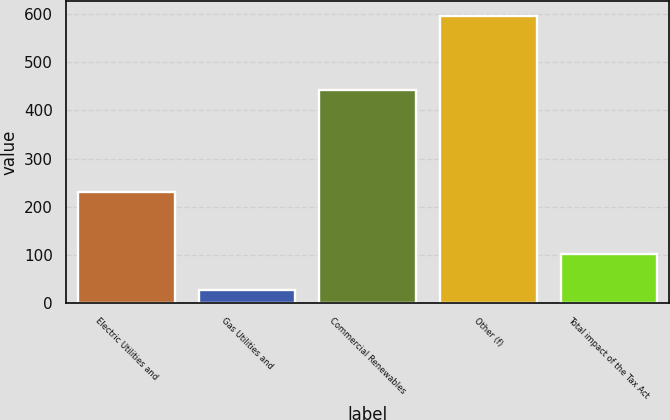Convert chart to OTSL. <chart><loc_0><loc_0><loc_500><loc_500><bar_chart><fcel>Electric Utilities and<fcel>Gas Utilities and<fcel>Commercial Renewables<fcel>Other (f)<fcel>Total impact of the Tax Act<nl><fcel>231<fcel>26<fcel>442<fcel>597<fcel>102<nl></chart> 